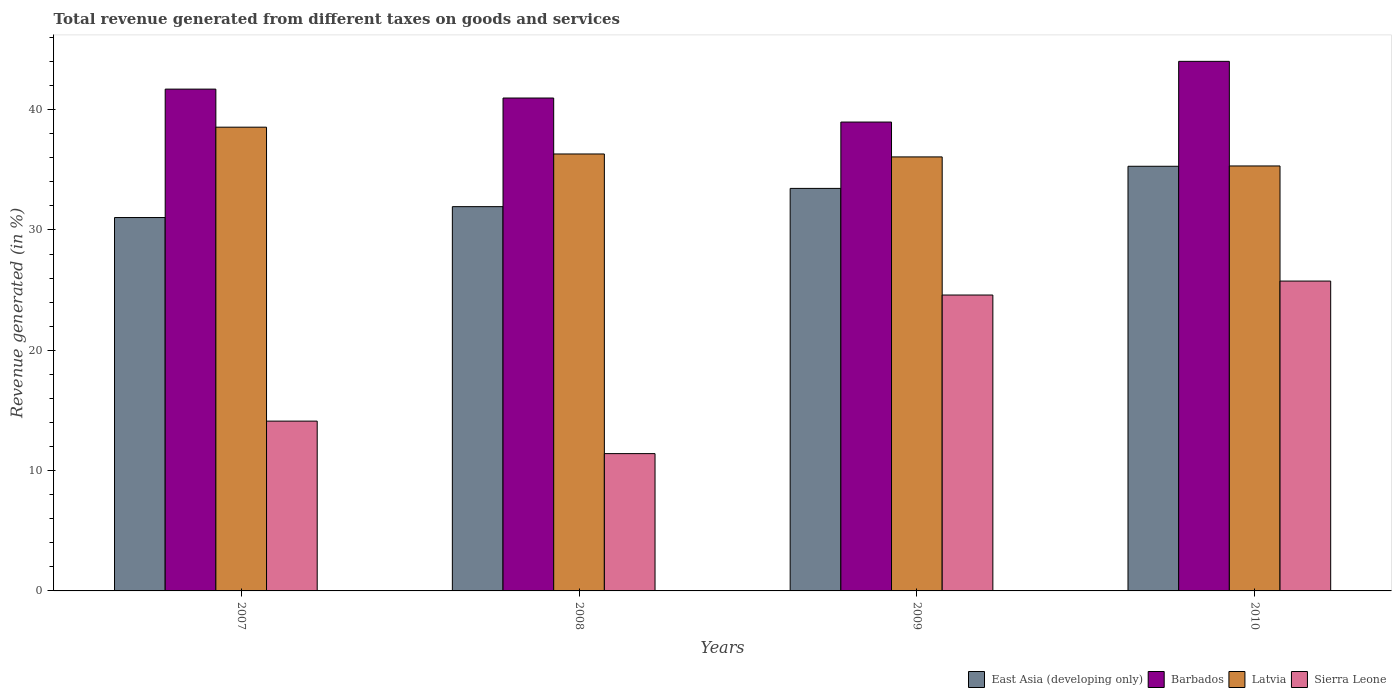How many groups of bars are there?
Ensure brevity in your answer.  4. Are the number of bars per tick equal to the number of legend labels?
Offer a very short reply. Yes. Are the number of bars on each tick of the X-axis equal?
Give a very brief answer. Yes. How many bars are there on the 3rd tick from the left?
Make the answer very short. 4. What is the label of the 2nd group of bars from the left?
Offer a very short reply. 2008. What is the total revenue generated in East Asia (developing only) in 2010?
Make the answer very short. 35.29. Across all years, what is the maximum total revenue generated in Barbados?
Offer a very short reply. 44.01. Across all years, what is the minimum total revenue generated in Sierra Leone?
Offer a very short reply. 11.41. In which year was the total revenue generated in Sierra Leone maximum?
Your response must be concise. 2010. In which year was the total revenue generated in Sierra Leone minimum?
Offer a very short reply. 2008. What is the total total revenue generated in Sierra Leone in the graph?
Provide a short and direct response. 75.86. What is the difference between the total revenue generated in East Asia (developing only) in 2008 and that in 2009?
Ensure brevity in your answer.  -1.52. What is the difference between the total revenue generated in East Asia (developing only) in 2010 and the total revenue generated in Sierra Leone in 2009?
Give a very brief answer. 10.7. What is the average total revenue generated in East Asia (developing only) per year?
Make the answer very short. 32.93. In the year 2007, what is the difference between the total revenue generated in Sierra Leone and total revenue generated in Barbados?
Offer a terse response. -27.59. In how many years, is the total revenue generated in Sierra Leone greater than 10 %?
Provide a succinct answer. 4. What is the ratio of the total revenue generated in Latvia in 2007 to that in 2010?
Offer a very short reply. 1.09. Is the total revenue generated in Barbados in 2008 less than that in 2009?
Keep it short and to the point. No. Is the difference between the total revenue generated in Sierra Leone in 2008 and 2010 greater than the difference between the total revenue generated in Barbados in 2008 and 2010?
Your answer should be compact. No. What is the difference between the highest and the second highest total revenue generated in East Asia (developing only)?
Keep it short and to the point. 1.84. What is the difference between the highest and the lowest total revenue generated in East Asia (developing only)?
Give a very brief answer. 4.26. In how many years, is the total revenue generated in East Asia (developing only) greater than the average total revenue generated in East Asia (developing only) taken over all years?
Your response must be concise. 2. Is it the case that in every year, the sum of the total revenue generated in Barbados and total revenue generated in Latvia is greater than the sum of total revenue generated in East Asia (developing only) and total revenue generated in Sierra Leone?
Make the answer very short. No. What does the 3rd bar from the left in 2009 represents?
Give a very brief answer. Latvia. What does the 4th bar from the right in 2008 represents?
Keep it short and to the point. East Asia (developing only). Is it the case that in every year, the sum of the total revenue generated in Latvia and total revenue generated in Sierra Leone is greater than the total revenue generated in Barbados?
Your response must be concise. Yes. How many bars are there?
Keep it short and to the point. 16. Are all the bars in the graph horizontal?
Provide a succinct answer. No. Does the graph contain any zero values?
Keep it short and to the point. No. Where does the legend appear in the graph?
Give a very brief answer. Bottom right. What is the title of the graph?
Keep it short and to the point. Total revenue generated from different taxes on goods and services. Does "India" appear as one of the legend labels in the graph?
Make the answer very short. No. What is the label or title of the Y-axis?
Make the answer very short. Revenue generated (in %). What is the Revenue generated (in %) of East Asia (developing only) in 2007?
Offer a terse response. 31.03. What is the Revenue generated (in %) of Barbados in 2007?
Keep it short and to the point. 41.7. What is the Revenue generated (in %) in Latvia in 2007?
Offer a terse response. 38.54. What is the Revenue generated (in %) of Sierra Leone in 2007?
Make the answer very short. 14.11. What is the Revenue generated (in %) of East Asia (developing only) in 2008?
Offer a very short reply. 31.94. What is the Revenue generated (in %) of Barbados in 2008?
Your answer should be compact. 40.96. What is the Revenue generated (in %) in Latvia in 2008?
Provide a short and direct response. 36.31. What is the Revenue generated (in %) in Sierra Leone in 2008?
Offer a terse response. 11.41. What is the Revenue generated (in %) in East Asia (developing only) in 2009?
Offer a very short reply. 33.45. What is the Revenue generated (in %) of Barbados in 2009?
Make the answer very short. 38.97. What is the Revenue generated (in %) of Latvia in 2009?
Offer a terse response. 36.07. What is the Revenue generated (in %) in Sierra Leone in 2009?
Provide a succinct answer. 24.59. What is the Revenue generated (in %) of East Asia (developing only) in 2010?
Provide a short and direct response. 35.29. What is the Revenue generated (in %) of Barbados in 2010?
Your answer should be very brief. 44.01. What is the Revenue generated (in %) of Latvia in 2010?
Offer a terse response. 35.32. What is the Revenue generated (in %) in Sierra Leone in 2010?
Ensure brevity in your answer.  25.75. Across all years, what is the maximum Revenue generated (in %) in East Asia (developing only)?
Keep it short and to the point. 35.29. Across all years, what is the maximum Revenue generated (in %) of Barbados?
Your response must be concise. 44.01. Across all years, what is the maximum Revenue generated (in %) of Latvia?
Your response must be concise. 38.54. Across all years, what is the maximum Revenue generated (in %) of Sierra Leone?
Give a very brief answer. 25.75. Across all years, what is the minimum Revenue generated (in %) of East Asia (developing only)?
Make the answer very short. 31.03. Across all years, what is the minimum Revenue generated (in %) in Barbados?
Ensure brevity in your answer.  38.97. Across all years, what is the minimum Revenue generated (in %) in Latvia?
Your answer should be very brief. 35.32. Across all years, what is the minimum Revenue generated (in %) in Sierra Leone?
Provide a short and direct response. 11.41. What is the total Revenue generated (in %) of East Asia (developing only) in the graph?
Your answer should be compact. 131.71. What is the total Revenue generated (in %) in Barbados in the graph?
Provide a short and direct response. 165.64. What is the total Revenue generated (in %) in Latvia in the graph?
Make the answer very short. 146.24. What is the total Revenue generated (in %) of Sierra Leone in the graph?
Your answer should be very brief. 75.86. What is the difference between the Revenue generated (in %) of East Asia (developing only) in 2007 and that in 2008?
Your answer should be very brief. -0.91. What is the difference between the Revenue generated (in %) in Barbados in 2007 and that in 2008?
Your answer should be very brief. 0.74. What is the difference between the Revenue generated (in %) in Latvia in 2007 and that in 2008?
Your response must be concise. 2.23. What is the difference between the Revenue generated (in %) of Sierra Leone in 2007 and that in 2008?
Provide a succinct answer. 2.7. What is the difference between the Revenue generated (in %) of East Asia (developing only) in 2007 and that in 2009?
Provide a short and direct response. -2.42. What is the difference between the Revenue generated (in %) of Barbados in 2007 and that in 2009?
Provide a short and direct response. 2.74. What is the difference between the Revenue generated (in %) in Latvia in 2007 and that in 2009?
Ensure brevity in your answer.  2.47. What is the difference between the Revenue generated (in %) in Sierra Leone in 2007 and that in 2009?
Ensure brevity in your answer.  -10.48. What is the difference between the Revenue generated (in %) in East Asia (developing only) in 2007 and that in 2010?
Provide a succinct answer. -4.26. What is the difference between the Revenue generated (in %) of Barbados in 2007 and that in 2010?
Keep it short and to the point. -2.31. What is the difference between the Revenue generated (in %) in Latvia in 2007 and that in 2010?
Provide a short and direct response. 3.22. What is the difference between the Revenue generated (in %) in Sierra Leone in 2007 and that in 2010?
Ensure brevity in your answer.  -11.64. What is the difference between the Revenue generated (in %) in East Asia (developing only) in 2008 and that in 2009?
Give a very brief answer. -1.52. What is the difference between the Revenue generated (in %) in Barbados in 2008 and that in 2009?
Offer a very short reply. 2. What is the difference between the Revenue generated (in %) in Latvia in 2008 and that in 2009?
Provide a succinct answer. 0.24. What is the difference between the Revenue generated (in %) of Sierra Leone in 2008 and that in 2009?
Give a very brief answer. -13.18. What is the difference between the Revenue generated (in %) of East Asia (developing only) in 2008 and that in 2010?
Your answer should be compact. -3.35. What is the difference between the Revenue generated (in %) of Barbados in 2008 and that in 2010?
Your response must be concise. -3.05. What is the difference between the Revenue generated (in %) in Sierra Leone in 2008 and that in 2010?
Make the answer very short. -14.34. What is the difference between the Revenue generated (in %) of East Asia (developing only) in 2009 and that in 2010?
Your answer should be very brief. -1.84. What is the difference between the Revenue generated (in %) in Barbados in 2009 and that in 2010?
Your response must be concise. -5.04. What is the difference between the Revenue generated (in %) in Latvia in 2009 and that in 2010?
Offer a terse response. 0.75. What is the difference between the Revenue generated (in %) of Sierra Leone in 2009 and that in 2010?
Offer a very short reply. -1.16. What is the difference between the Revenue generated (in %) in East Asia (developing only) in 2007 and the Revenue generated (in %) in Barbados in 2008?
Your answer should be compact. -9.93. What is the difference between the Revenue generated (in %) of East Asia (developing only) in 2007 and the Revenue generated (in %) of Latvia in 2008?
Your answer should be compact. -5.28. What is the difference between the Revenue generated (in %) in East Asia (developing only) in 2007 and the Revenue generated (in %) in Sierra Leone in 2008?
Make the answer very short. 19.62. What is the difference between the Revenue generated (in %) in Barbados in 2007 and the Revenue generated (in %) in Latvia in 2008?
Your response must be concise. 5.39. What is the difference between the Revenue generated (in %) of Barbados in 2007 and the Revenue generated (in %) of Sierra Leone in 2008?
Make the answer very short. 30.29. What is the difference between the Revenue generated (in %) of Latvia in 2007 and the Revenue generated (in %) of Sierra Leone in 2008?
Give a very brief answer. 27.13. What is the difference between the Revenue generated (in %) of East Asia (developing only) in 2007 and the Revenue generated (in %) of Barbados in 2009?
Provide a short and direct response. -7.93. What is the difference between the Revenue generated (in %) in East Asia (developing only) in 2007 and the Revenue generated (in %) in Latvia in 2009?
Give a very brief answer. -5.04. What is the difference between the Revenue generated (in %) in East Asia (developing only) in 2007 and the Revenue generated (in %) in Sierra Leone in 2009?
Offer a terse response. 6.44. What is the difference between the Revenue generated (in %) of Barbados in 2007 and the Revenue generated (in %) of Latvia in 2009?
Your answer should be very brief. 5.63. What is the difference between the Revenue generated (in %) of Barbados in 2007 and the Revenue generated (in %) of Sierra Leone in 2009?
Give a very brief answer. 17.11. What is the difference between the Revenue generated (in %) in Latvia in 2007 and the Revenue generated (in %) in Sierra Leone in 2009?
Give a very brief answer. 13.95. What is the difference between the Revenue generated (in %) in East Asia (developing only) in 2007 and the Revenue generated (in %) in Barbados in 2010?
Provide a succinct answer. -12.98. What is the difference between the Revenue generated (in %) of East Asia (developing only) in 2007 and the Revenue generated (in %) of Latvia in 2010?
Offer a terse response. -4.29. What is the difference between the Revenue generated (in %) of East Asia (developing only) in 2007 and the Revenue generated (in %) of Sierra Leone in 2010?
Your answer should be compact. 5.28. What is the difference between the Revenue generated (in %) in Barbados in 2007 and the Revenue generated (in %) in Latvia in 2010?
Give a very brief answer. 6.39. What is the difference between the Revenue generated (in %) in Barbados in 2007 and the Revenue generated (in %) in Sierra Leone in 2010?
Ensure brevity in your answer.  15.95. What is the difference between the Revenue generated (in %) in Latvia in 2007 and the Revenue generated (in %) in Sierra Leone in 2010?
Ensure brevity in your answer.  12.79. What is the difference between the Revenue generated (in %) of East Asia (developing only) in 2008 and the Revenue generated (in %) of Barbados in 2009?
Make the answer very short. -7.03. What is the difference between the Revenue generated (in %) of East Asia (developing only) in 2008 and the Revenue generated (in %) of Latvia in 2009?
Your answer should be compact. -4.13. What is the difference between the Revenue generated (in %) in East Asia (developing only) in 2008 and the Revenue generated (in %) in Sierra Leone in 2009?
Make the answer very short. 7.34. What is the difference between the Revenue generated (in %) in Barbados in 2008 and the Revenue generated (in %) in Latvia in 2009?
Your answer should be very brief. 4.89. What is the difference between the Revenue generated (in %) of Barbados in 2008 and the Revenue generated (in %) of Sierra Leone in 2009?
Give a very brief answer. 16.37. What is the difference between the Revenue generated (in %) of Latvia in 2008 and the Revenue generated (in %) of Sierra Leone in 2009?
Ensure brevity in your answer.  11.72. What is the difference between the Revenue generated (in %) in East Asia (developing only) in 2008 and the Revenue generated (in %) in Barbados in 2010?
Your answer should be compact. -12.07. What is the difference between the Revenue generated (in %) of East Asia (developing only) in 2008 and the Revenue generated (in %) of Latvia in 2010?
Provide a short and direct response. -3.38. What is the difference between the Revenue generated (in %) of East Asia (developing only) in 2008 and the Revenue generated (in %) of Sierra Leone in 2010?
Your answer should be compact. 6.19. What is the difference between the Revenue generated (in %) of Barbados in 2008 and the Revenue generated (in %) of Latvia in 2010?
Ensure brevity in your answer.  5.65. What is the difference between the Revenue generated (in %) in Barbados in 2008 and the Revenue generated (in %) in Sierra Leone in 2010?
Offer a terse response. 15.21. What is the difference between the Revenue generated (in %) in Latvia in 2008 and the Revenue generated (in %) in Sierra Leone in 2010?
Your response must be concise. 10.56. What is the difference between the Revenue generated (in %) of East Asia (developing only) in 2009 and the Revenue generated (in %) of Barbados in 2010?
Your answer should be very brief. -10.56. What is the difference between the Revenue generated (in %) in East Asia (developing only) in 2009 and the Revenue generated (in %) in Latvia in 2010?
Your answer should be compact. -1.86. What is the difference between the Revenue generated (in %) in East Asia (developing only) in 2009 and the Revenue generated (in %) in Sierra Leone in 2010?
Your answer should be compact. 7.7. What is the difference between the Revenue generated (in %) in Barbados in 2009 and the Revenue generated (in %) in Latvia in 2010?
Offer a very short reply. 3.65. What is the difference between the Revenue generated (in %) in Barbados in 2009 and the Revenue generated (in %) in Sierra Leone in 2010?
Your response must be concise. 13.21. What is the difference between the Revenue generated (in %) in Latvia in 2009 and the Revenue generated (in %) in Sierra Leone in 2010?
Give a very brief answer. 10.32. What is the average Revenue generated (in %) of East Asia (developing only) per year?
Provide a short and direct response. 32.93. What is the average Revenue generated (in %) of Barbados per year?
Your answer should be very brief. 41.41. What is the average Revenue generated (in %) of Latvia per year?
Provide a short and direct response. 36.56. What is the average Revenue generated (in %) in Sierra Leone per year?
Your answer should be compact. 18.97. In the year 2007, what is the difference between the Revenue generated (in %) of East Asia (developing only) and Revenue generated (in %) of Barbados?
Offer a terse response. -10.67. In the year 2007, what is the difference between the Revenue generated (in %) in East Asia (developing only) and Revenue generated (in %) in Latvia?
Your answer should be compact. -7.51. In the year 2007, what is the difference between the Revenue generated (in %) in East Asia (developing only) and Revenue generated (in %) in Sierra Leone?
Your answer should be very brief. 16.92. In the year 2007, what is the difference between the Revenue generated (in %) of Barbados and Revenue generated (in %) of Latvia?
Give a very brief answer. 3.16. In the year 2007, what is the difference between the Revenue generated (in %) of Barbados and Revenue generated (in %) of Sierra Leone?
Offer a terse response. 27.59. In the year 2007, what is the difference between the Revenue generated (in %) in Latvia and Revenue generated (in %) in Sierra Leone?
Your answer should be very brief. 24.43. In the year 2008, what is the difference between the Revenue generated (in %) in East Asia (developing only) and Revenue generated (in %) in Barbados?
Offer a terse response. -9.03. In the year 2008, what is the difference between the Revenue generated (in %) of East Asia (developing only) and Revenue generated (in %) of Latvia?
Give a very brief answer. -4.38. In the year 2008, what is the difference between the Revenue generated (in %) in East Asia (developing only) and Revenue generated (in %) in Sierra Leone?
Keep it short and to the point. 20.53. In the year 2008, what is the difference between the Revenue generated (in %) of Barbados and Revenue generated (in %) of Latvia?
Your answer should be compact. 4.65. In the year 2008, what is the difference between the Revenue generated (in %) of Barbados and Revenue generated (in %) of Sierra Leone?
Provide a short and direct response. 29.55. In the year 2008, what is the difference between the Revenue generated (in %) in Latvia and Revenue generated (in %) in Sierra Leone?
Provide a short and direct response. 24.9. In the year 2009, what is the difference between the Revenue generated (in %) of East Asia (developing only) and Revenue generated (in %) of Barbados?
Your answer should be very brief. -5.51. In the year 2009, what is the difference between the Revenue generated (in %) of East Asia (developing only) and Revenue generated (in %) of Latvia?
Your answer should be very brief. -2.62. In the year 2009, what is the difference between the Revenue generated (in %) of East Asia (developing only) and Revenue generated (in %) of Sierra Leone?
Make the answer very short. 8.86. In the year 2009, what is the difference between the Revenue generated (in %) of Barbados and Revenue generated (in %) of Latvia?
Your answer should be very brief. 2.9. In the year 2009, what is the difference between the Revenue generated (in %) in Barbados and Revenue generated (in %) in Sierra Leone?
Ensure brevity in your answer.  14.37. In the year 2009, what is the difference between the Revenue generated (in %) of Latvia and Revenue generated (in %) of Sierra Leone?
Offer a very short reply. 11.48. In the year 2010, what is the difference between the Revenue generated (in %) of East Asia (developing only) and Revenue generated (in %) of Barbados?
Make the answer very short. -8.72. In the year 2010, what is the difference between the Revenue generated (in %) of East Asia (developing only) and Revenue generated (in %) of Latvia?
Offer a terse response. -0.03. In the year 2010, what is the difference between the Revenue generated (in %) of East Asia (developing only) and Revenue generated (in %) of Sierra Leone?
Your response must be concise. 9.54. In the year 2010, what is the difference between the Revenue generated (in %) of Barbados and Revenue generated (in %) of Latvia?
Make the answer very short. 8.69. In the year 2010, what is the difference between the Revenue generated (in %) in Barbados and Revenue generated (in %) in Sierra Leone?
Your response must be concise. 18.26. In the year 2010, what is the difference between the Revenue generated (in %) of Latvia and Revenue generated (in %) of Sierra Leone?
Make the answer very short. 9.57. What is the ratio of the Revenue generated (in %) of East Asia (developing only) in 2007 to that in 2008?
Offer a very short reply. 0.97. What is the ratio of the Revenue generated (in %) of Barbados in 2007 to that in 2008?
Your answer should be compact. 1.02. What is the ratio of the Revenue generated (in %) in Latvia in 2007 to that in 2008?
Make the answer very short. 1.06. What is the ratio of the Revenue generated (in %) in Sierra Leone in 2007 to that in 2008?
Offer a very short reply. 1.24. What is the ratio of the Revenue generated (in %) in East Asia (developing only) in 2007 to that in 2009?
Make the answer very short. 0.93. What is the ratio of the Revenue generated (in %) in Barbados in 2007 to that in 2009?
Offer a terse response. 1.07. What is the ratio of the Revenue generated (in %) of Latvia in 2007 to that in 2009?
Offer a very short reply. 1.07. What is the ratio of the Revenue generated (in %) of Sierra Leone in 2007 to that in 2009?
Ensure brevity in your answer.  0.57. What is the ratio of the Revenue generated (in %) of East Asia (developing only) in 2007 to that in 2010?
Offer a very short reply. 0.88. What is the ratio of the Revenue generated (in %) in Barbados in 2007 to that in 2010?
Ensure brevity in your answer.  0.95. What is the ratio of the Revenue generated (in %) in Latvia in 2007 to that in 2010?
Provide a short and direct response. 1.09. What is the ratio of the Revenue generated (in %) in Sierra Leone in 2007 to that in 2010?
Your answer should be compact. 0.55. What is the ratio of the Revenue generated (in %) of East Asia (developing only) in 2008 to that in 2009?
Offer a terse response. 0.95. What is the ratio of the Revenue generated (in %) of Barbados in 2008 to that in 2009?
Your response must be concise. 1.05. What is the ratio of the Revenue generated (in %) of Latvia in 2008 to that in 2009?
Give a very brief answer. 1.01. What is the ratio of the Revenue generated (in %) of Sierra Leone in 2008 to that in 2009?
Offer a terse response. 0.46. What is the ratio of the Revenue generated (in %) of East Asia (developing only) in 2008 to that in 2010?
Make the answer very short. 0.9. What is the ratio of the Revenue generated (in %) in Barbados in 2008 to that in 2010?
Your answer should be compact. 0.93. What is the ratio of the Revenue generated (in %) of Latvia in 2008 to that in 2010?
Give a very brief answer. 1.03. What is the ratio of the Revenue generated (in %) in Sierra Leone in 2008 to that in 2010?
Your response must be concise. 0.44. What is the ratio of the Revenue generated (in %) in East Asia (developing only) in 2009 to that in 2010?
Keep it short and to the point. 0.95. What is the ratio of the Revenue generated (in %) of Barbados in 2009 to that in 2010?
Your answer should be compact. 0.89. What is the ratio of the Revenue generated (in %) of Latvia in 2009 to that in 2010?
Your answer should be compact. 1.02. What is the ratio of the Revenue generated (in %) in Sierra Leone in 2009 to that in 2010?
Keep it short and to the point. 0.95. What is the difference between the highest and the second highest Revenue generated (in %) of East Asia (developing only)?
Provide a succinct answer. 1.84. What is the difference between the highest and the second highest Revenue generated (in %) of Barbados?
Make the answer very short. 2.31. What is the difference between the highest and the second highest Revenue generated (in %) of Latvia?
Provide a short and direct response. 2.23. What is the difference between the highest and the second highest Revenue generated (in %) of Sierra Leone?
Ensure brevity in your answer.  1.16. What is the difference between the highest and the lowest Revenue generated (in %) of East Asia (developing only)?
Your answer should be very brief. 4.26. What is the difference between the highest and the lowest Revenue generated (in %) in Barbados?
Your response must be concise. 5.04. What is the difference between the highest and the lowest Revenue generated (in %) of Latvia?
Ensure brevity in your answer.  3.22. What is the difference between the highest and the lowest Revenue generated (in %) in Sierra Leone?
Provide a short and direct response. 14.34. 